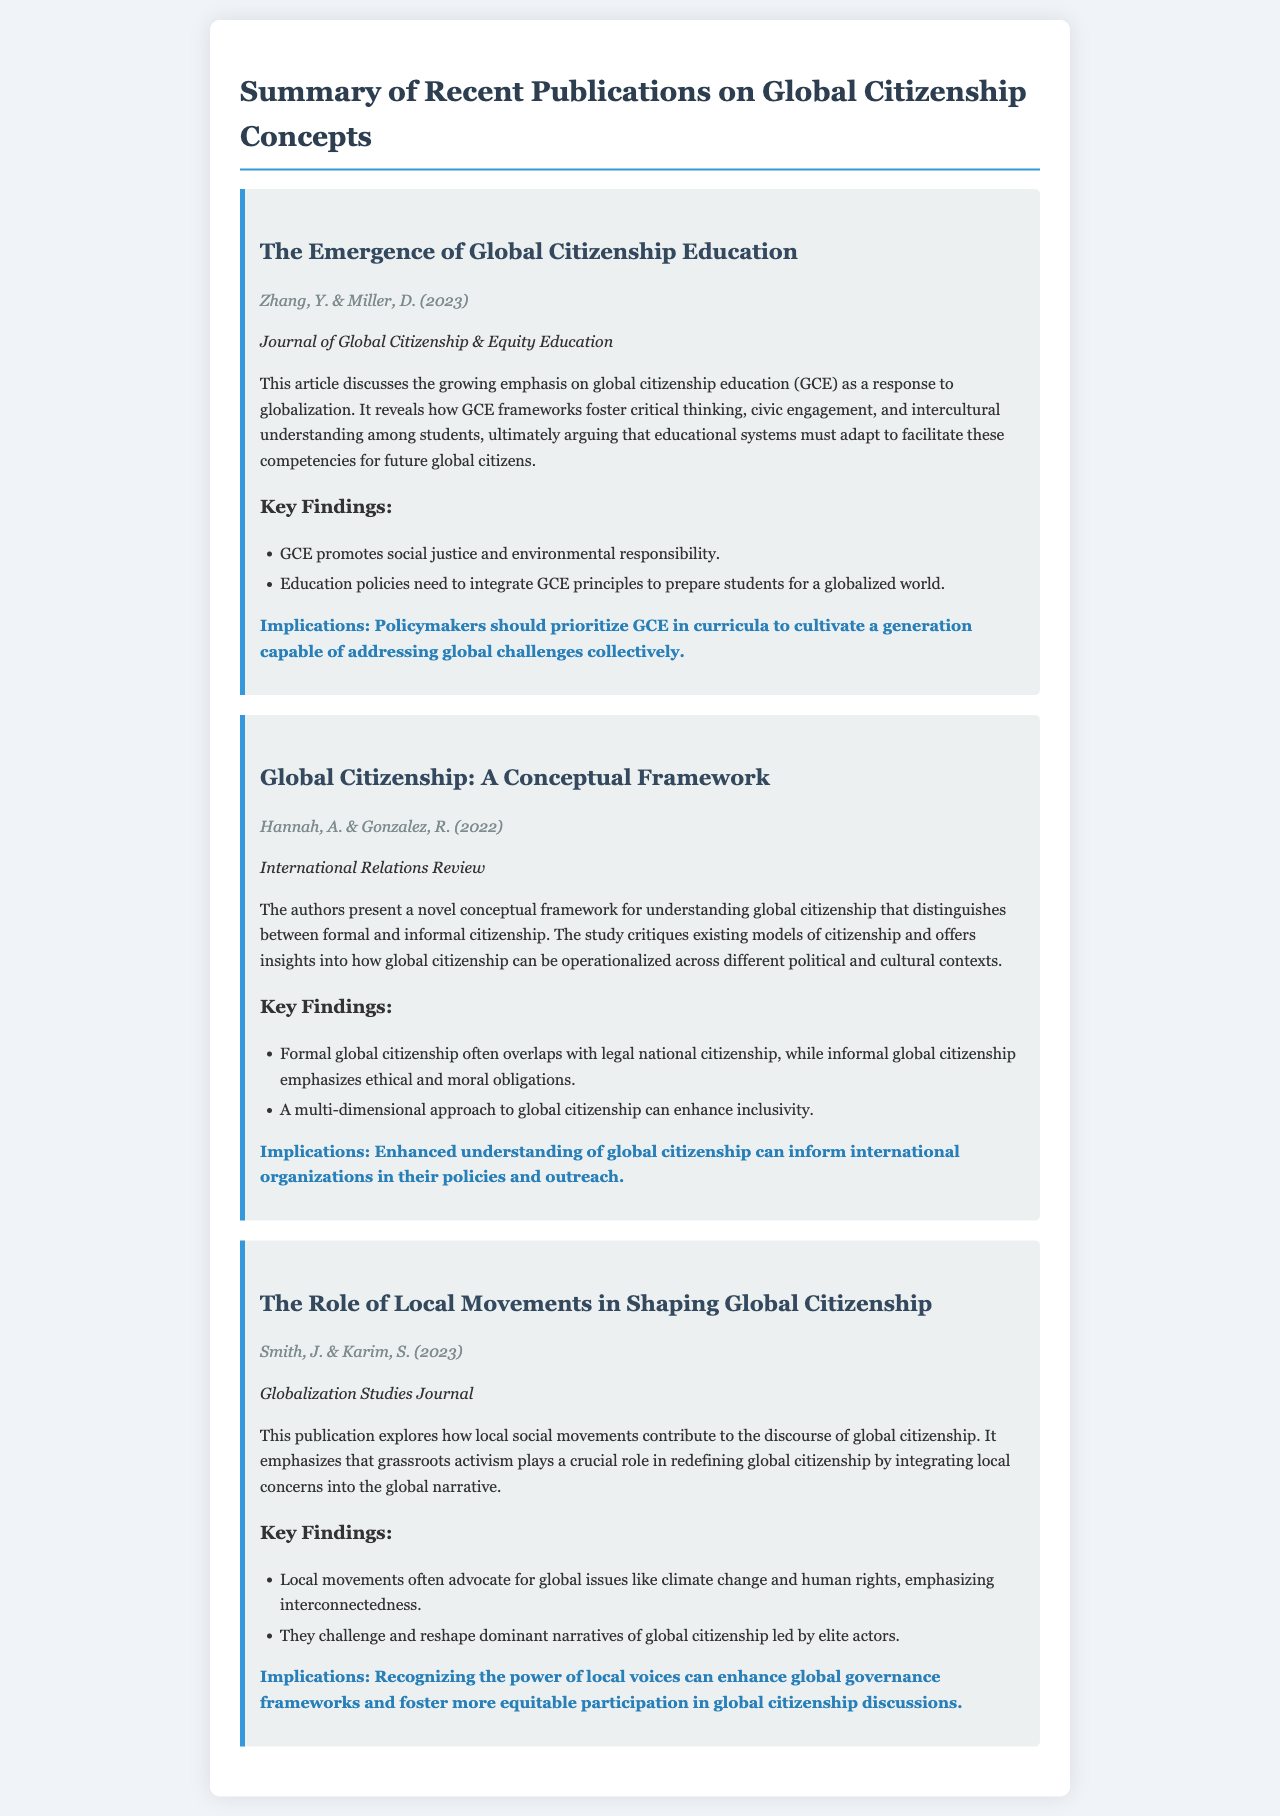What is the title of the first publication? The first publication is titled "The Emergence of Global Citizenship Education."
Answer: The Emergence of Global Citizenship Education Who are the authors of the second publication? The authors of the second publication are Hannah, A. & Gonzalez, R.
Answer: Hannah, A. & Gonzalez, R What year was the article on local movements published? The article on local movements was published in 2023.
Answer: 2023 What is one key finding from the publication by Zhang and Miller? One key finding is that GCE promotes social justice and environmental responsibility.
Answer: GCE promotes social justice and environmental responsibility What is a major implication of the conceptual framework presented by Hannah and Gonzalez? A major implication is that enhanced understanding of global citizenship can inform international organizations in their policies and outreach.
Answer: Enhanced understanding of global citizenship can inform international organizations in their policies and outreach What does the article by Smith and Karim emphasize about grassroots activism? The article emphasizes that grassroots activism plays a crucial role in redefining global citizenship.
Answer: Grassroots activism plays a crucial role in redefining global citizenship In which journal was the article on global citizenship education published? The article on global citizenship education was published in the Journal of Global Citizenship & Equity Education.
Answer: Journal of Global Citizenship & Equity Education How does the publication by Smith and Karim relate local movements to global citizenship? It relates local movements to global citizenship by stating that they contribute to the discourse of global citizenship.
Answer: They contribute to the discourse of global citizenship 